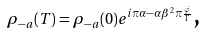Convert formula to latex. <formula><loc_0><loc_0><loc_500><loc_500>\rho _ { - a } ( T ) = \rho _ { - a } ( 0 ) e ^ { i \pi \alpha - \alpha \beta ^ { 2 } \pi \frac { \dot { \varphi } } { \Gamma } } \text {,}</formula> 